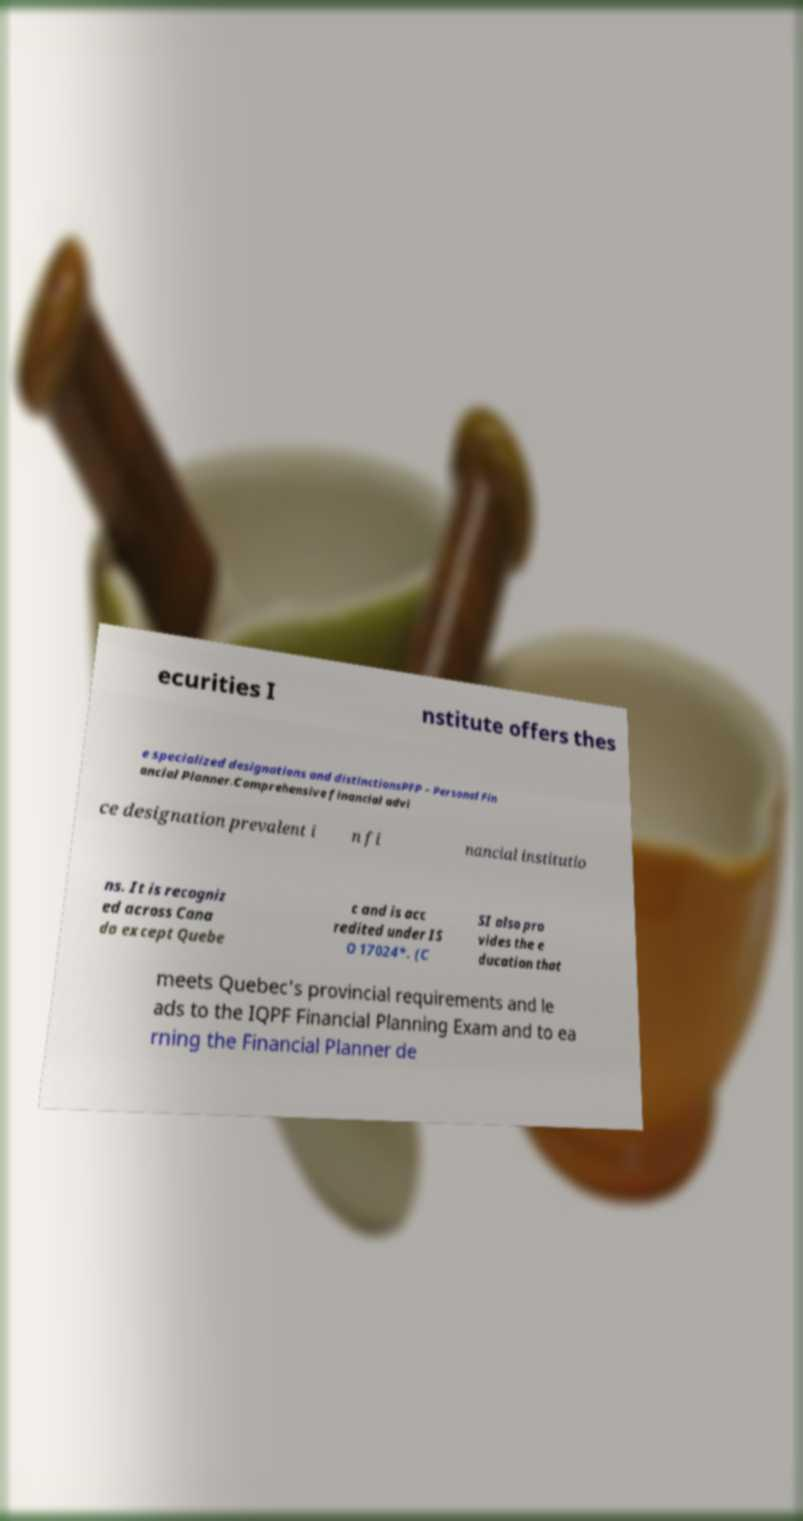Please identify and transcribe the text found in this image. ecurities I nstitute offers thes e specialized designations and distinctionsPFP – Personal Fin ancial Planner.Comprehensive financial advi ce designation prevalent i n fi nancial institutio ns. It is recogniz ed across Cana da except Quebe c and is acc redited under IS O 17024*. (C SI also pro vides the e ducation that meets Quebec's provincial requirements and le ads to the IQPF Financial Planning Exam and to ea rning the Financial Planner de 